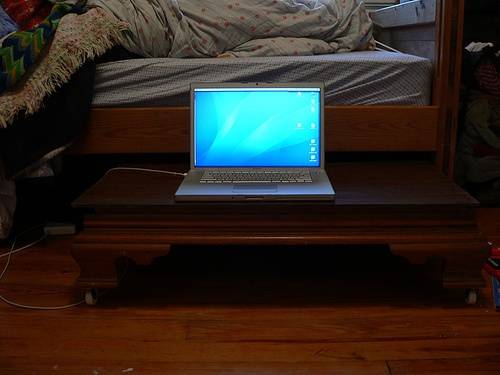Describe the objects in this image and their specific colors. I can see bed in black, gray, and maroon tones and laptop in black, cyan, gray, and lightblue tones in this image. 